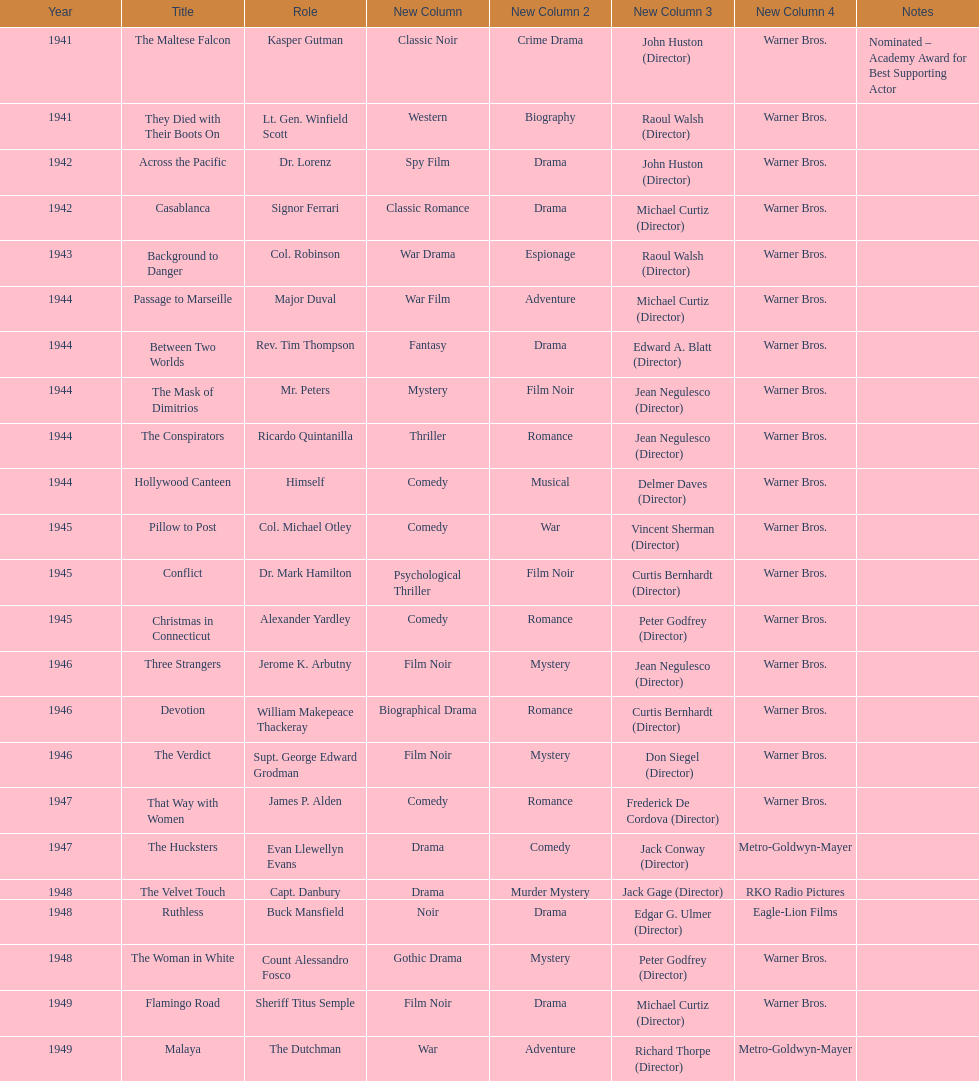What were the first and last movies greenstreet acted in? The Maltese Falcon, Malaya. 